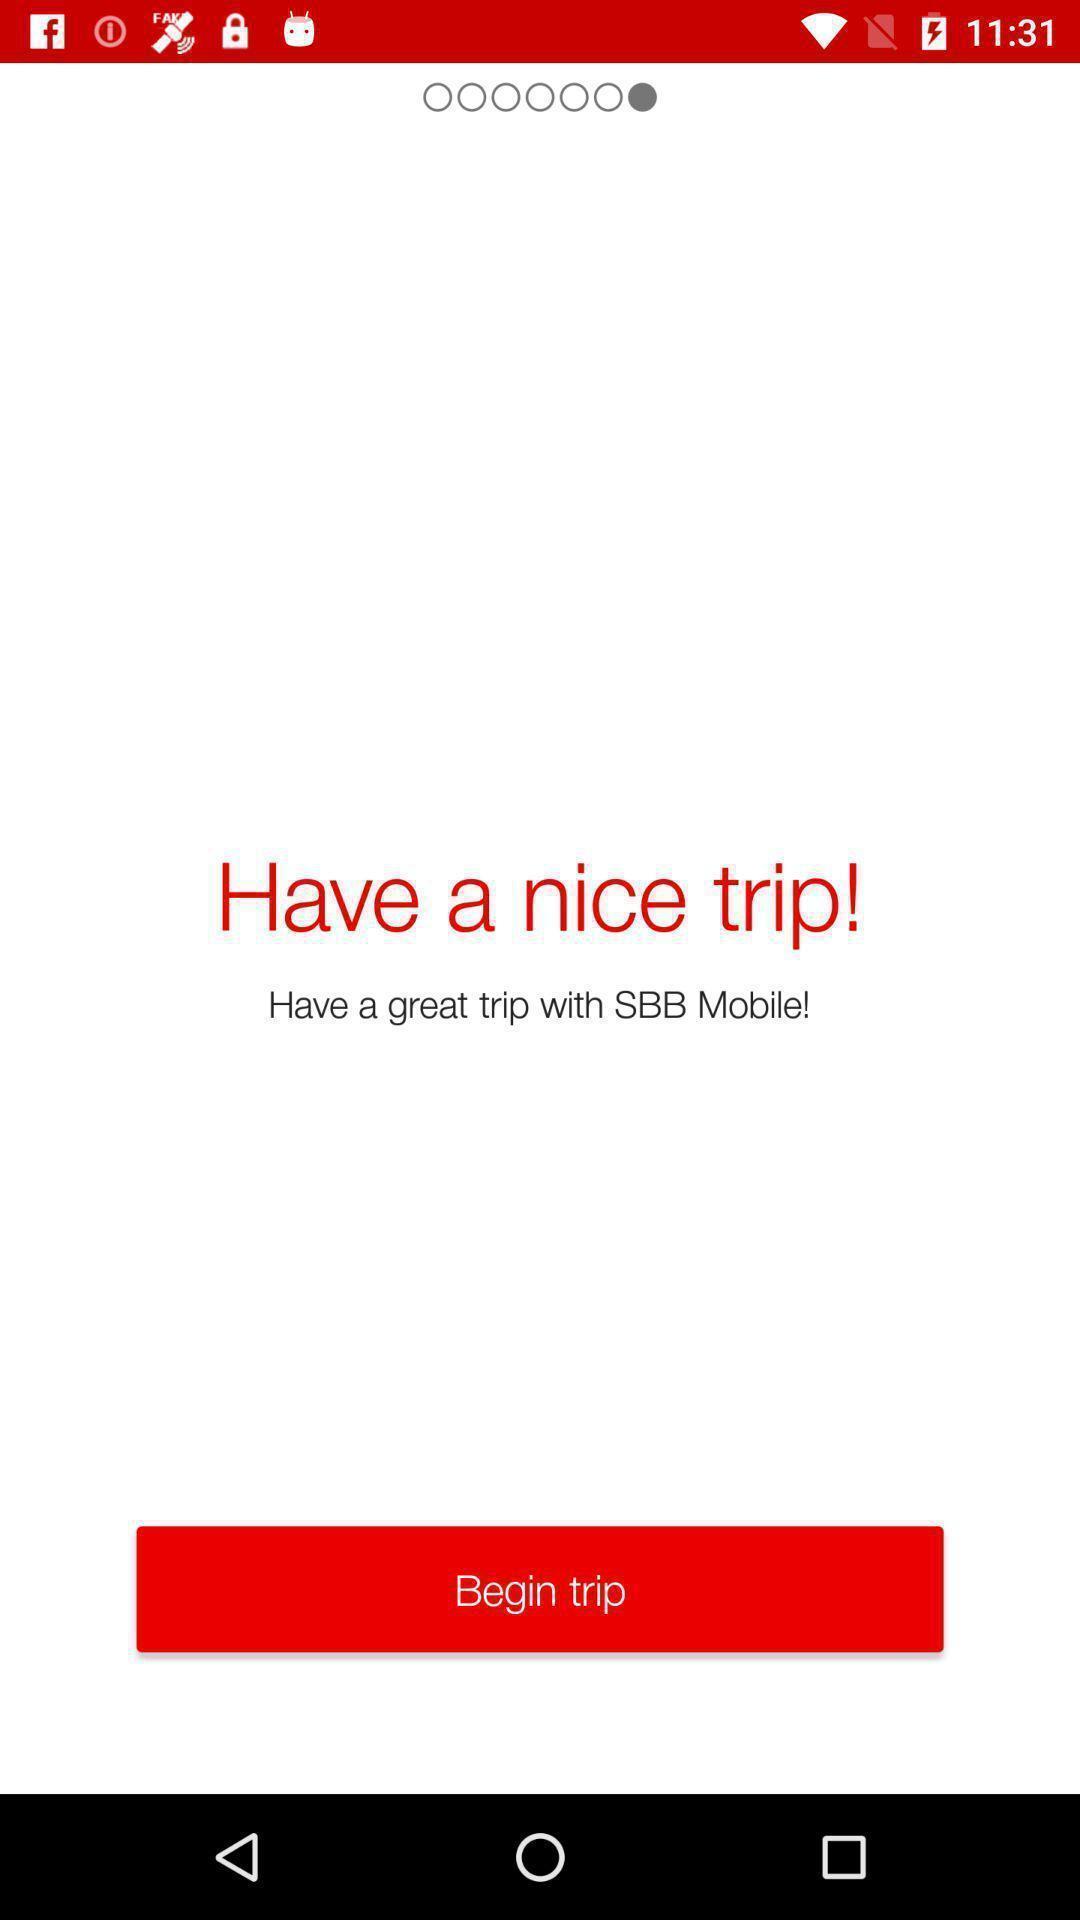Give me a narrative description of this picture. Welcome page of a trip booking application. 